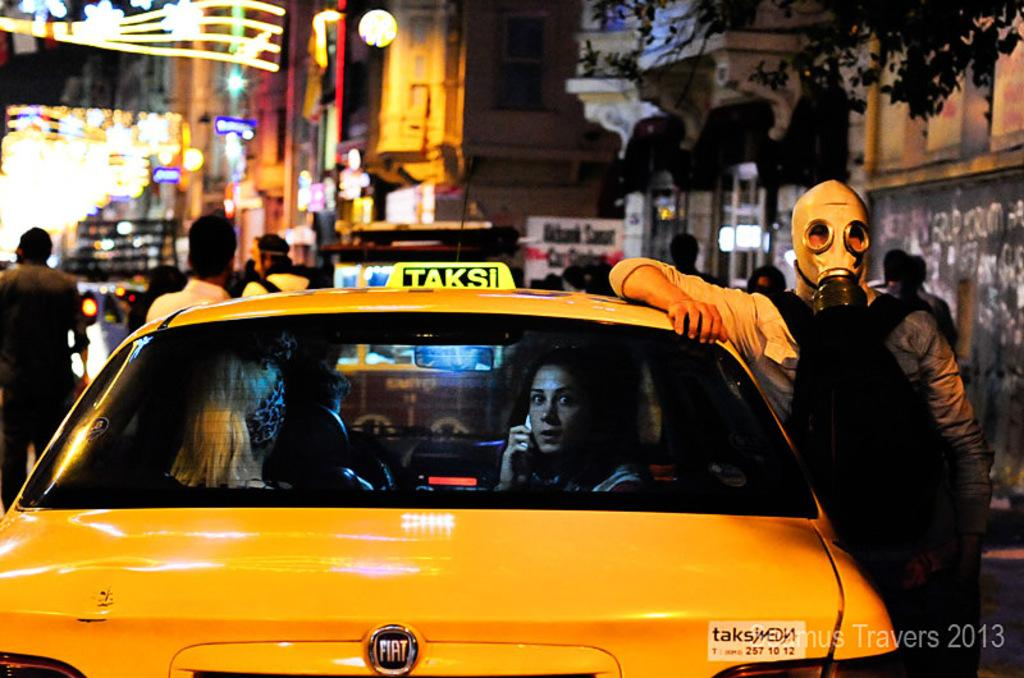Provide a one-sentence caption for the provided image. The man with the gas mask is leaning on yellow car with the medallion reading TAKSI. 